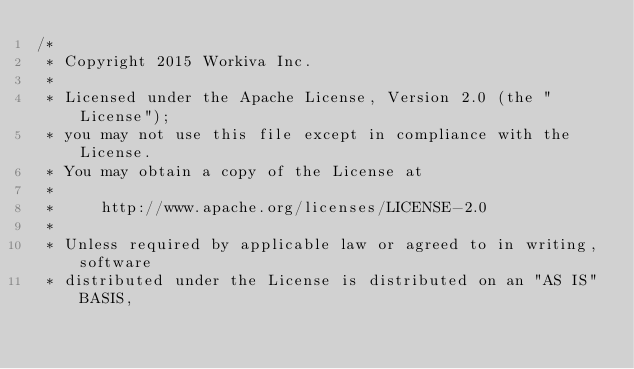Convert code to text. <code><loc_0><loc_0><loc_500><loc_500><_JavaScript_>/*
 * Copyright 2015 Workiva Inc.
 *
 * Licensed under the Apache License, Version 2.0 (the "License");
 * you may not use this file except in compliance with the License.
 * You may obtain a copy of the License at
 *
 *     http://www.apache.org/licenses/LICENSE-2.0
 *
 * Unless required by applicable law or agreed to in writing, software
 * distributed under the License is distributed on an "AS IS" BASIS,</code> 